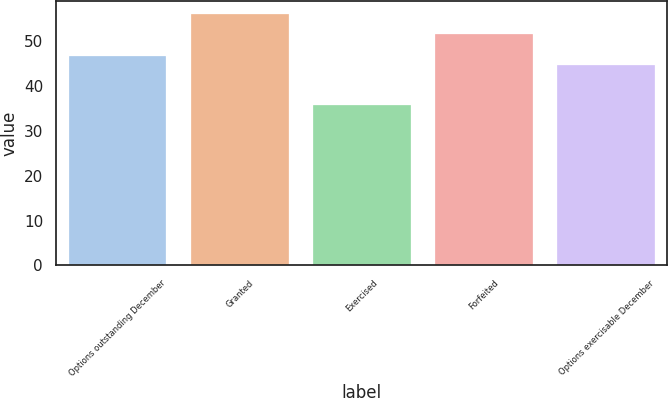Convert chart. <chart><loc_0><loc_0><loc_500><loc_500><bar_chart><fcel>Options outstanding December<fcel>Granted<fcel>Exercised<fcel>Forfeited<fcel>Options exercisable December<nl><fcel>46.8<fcel>56.17<fcel>35.73<fcel>51.66<fcel>44.76<nl></chart> 